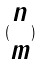<formula> <loc_0><loc_0><loc_500><loc_500>( \begin{matrix} n \\ m \end{matrix} )</formula> 